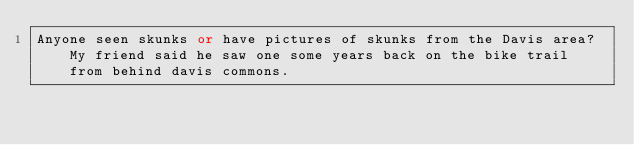<code> <loc_0><loc_0><loc_500><loc_500><_FORTRAN_>Anyone seen skunks or have pictures of skunks from the Davis area? My friend said he saw one some years back on the bike trail from behind davis commons.
</code> 